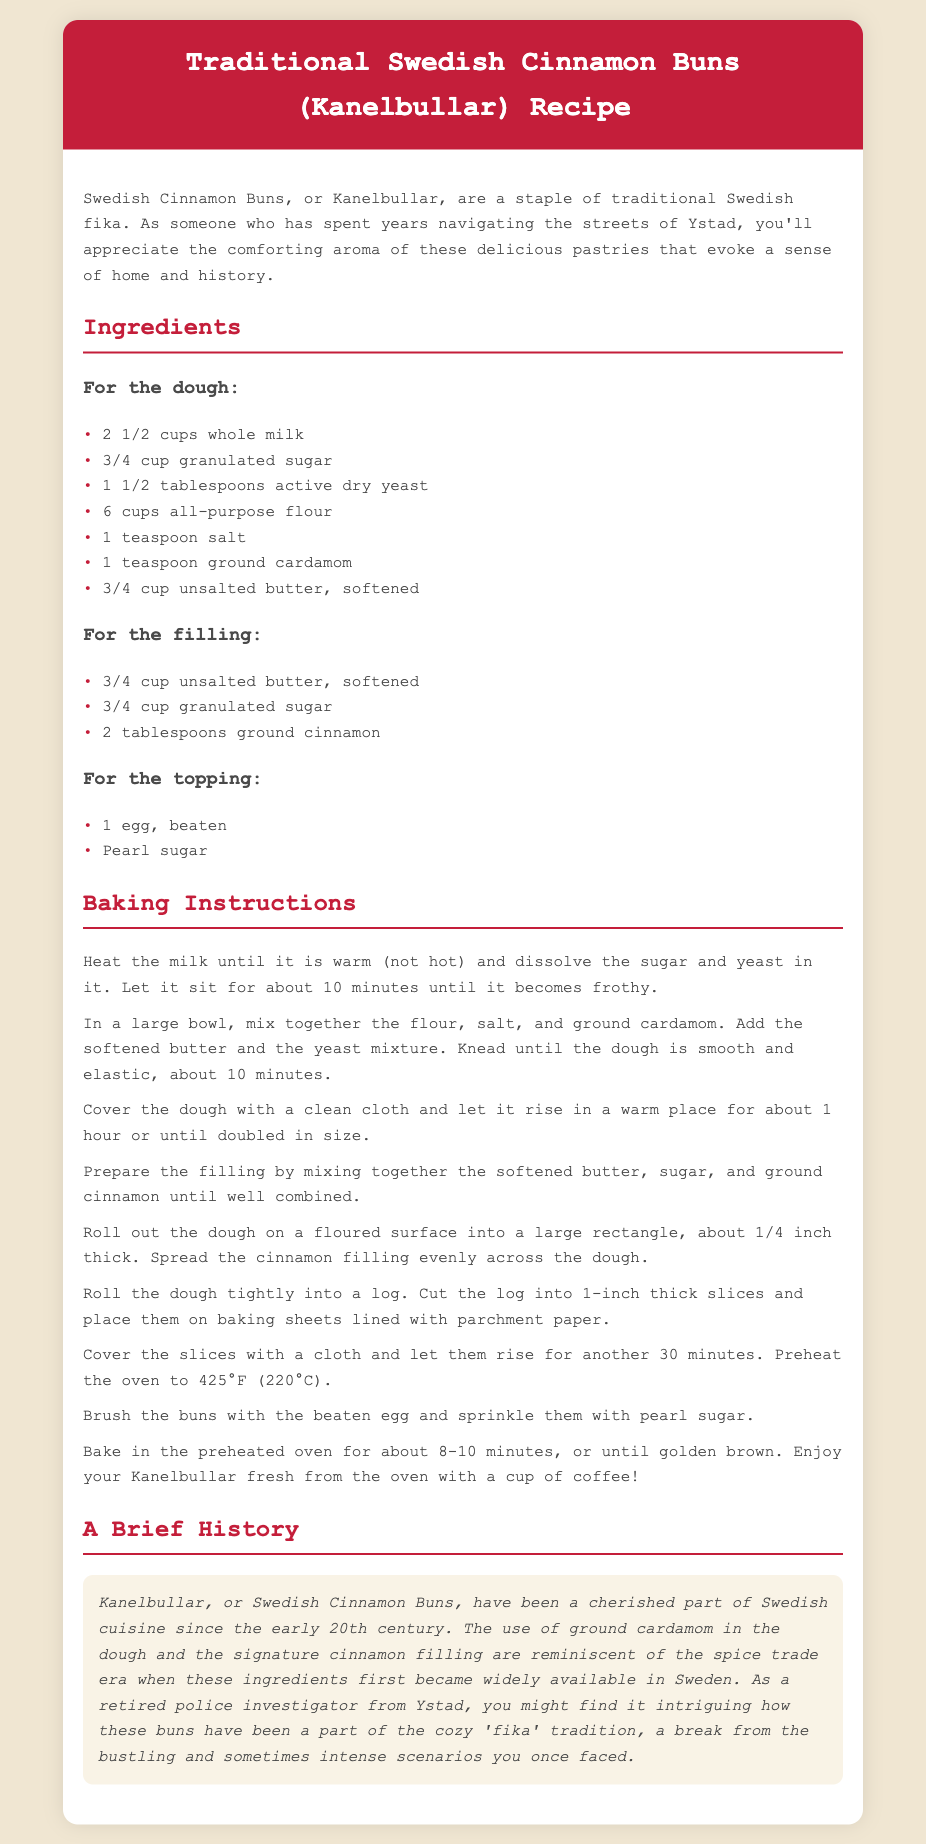what is the title of the recipe? The title of the recipe is provided in the header of the document.
Answer: Traditional Swedish Cinnamon Buns (Kanelbullar) Recipe how many cups of flour are needed? The amount of flour is specified in the ingredients section of the document.
Answer: 6 cups what is the baking temperature in Celsius? The baking temperature is mentioned in the baking instructions.
Answer: 220°C how long should the dough rise for the first time? The rising time for the dough is indicated in the baking instructions.
Answer: 1 hour what spice is used in the dough? The specific spice used in the dough is mentioned in the ingredients list.
Answer: ground cardamom how many tablespoons of yeast are required? The amount of yeast needed is stated in the ingredients section.
Answer: 1 1/2 tablespoons what is the significance of Kanelbullar in Swedish culture? The document mentions the importance of Kanelbullar in relation to social customs in Sweden.
Answer: part of the fika tradition who might find the history of Kanelbullar intriguing? The document suggests a group of people who may appreciate the history of these buns.
Answer: a retired police investigator from Ystad what is the duration for baking the buns? The cooking time for the buns is specified in the baking instructions.
Answer: 8-10 minutes 